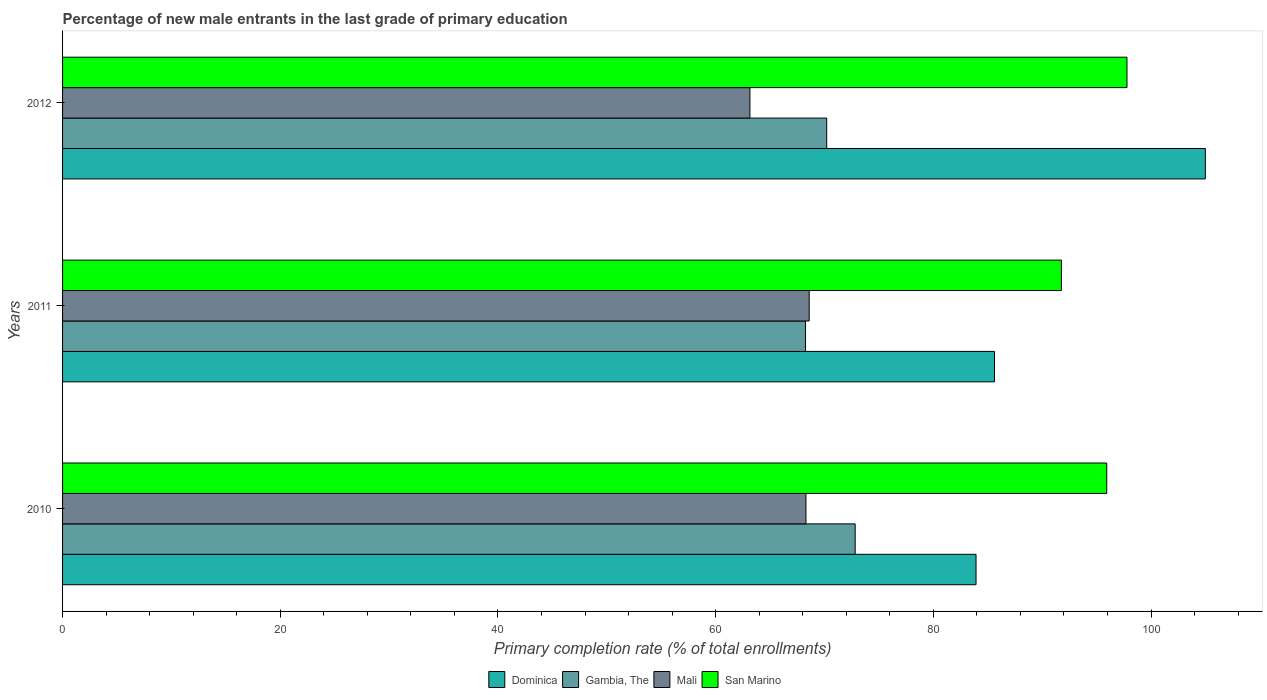How many different coloured bars are there?
Your answer should be compact. 4. Are the number of bars per tick equal to the number of legend labels?
Make the answer very short. Yes. What is the label of the 3rd group of bars from the top?
Make the answer very short. 2010. In how many cases, is the number of bars for a given year not equal to the number of legend labels?
Your answer should be very brief. 0. What is the percentage of new male entrants in Dominica in 2010?
Keep it short and to the point. 83.92. Across all years, what is the maximum percentage of new male entrants in Mali?
Make the answer very short. 68.6. Across all years, what is the minimum percentage of new male entrants in Mali?
Offer a very short reply. 63.15. What is the total percentage of new male entrants in San Marino in the graph?
Make the answer very short. 285.49. What is the difference between the percentage of new male entrants in Dominica in 2011 and that in 2012?
Your response must be concise. -19.37. What is the difference between the percentage of new male entrants in Gambia, The in 2011 and the percentage of new male entrants in San Marino in 2012?
Your response must be concise. -29.53. What is the average percentage of new male entrants in Gambia, The per year?
Your response must be concise. 70.43. In the year 2011, what is the difference between the percentage of new male entrants in Dominica and percentage of new male entrants in Gambia, The?
Provide a succinct answer. 17.36. In how many years, is the percentage of new male entrants in Dominica greater than 52 %?
Give a very brief answer. 3. What is the ratio of the percentage of new male entrants in Gambia, The in 2010 to that in 2012?
Offer a terse response. 1.04. Is the percentage of new male entrants in San Marino in 2011 less than that in 2012?
Provide a succinct answer. Yes. What is the difference between the highest and the second highest percentage of new male entrants in Mali?
Provide a short and direct response. 0.3. What is the difference between the highest and the lowest percentage of new male entrants in Dominica?
Your response must be concise. 21.07. In how many years, is the percentage of new male entrants in Mali greater than the average percentage of new male entrants in Mali taken over all years?
Ensure brevity in your answer.  2. Is the sum of the percentage of new male entrants in San Marino in 2010 and 2011 greater than the maximum percentage of new male entrants in Gambia, The across all years?
Ensure brevity in your answer.  Yes. Is it the case that in every year, the sum of the percentage of new male entrants in Dominica and percentage of new male entrants in Gambia, The is greater than the sum of percentage of new male entrants in San Marino and percentage of new male entrants in Mali?
Provide a short and direct response. Yes. What does the 3rd bar from the top in 2012 represents?
Provide a short and direct response. Gambia, The. What does the 4th bar from the bottom in 2010 represents?
Give a very brief answer. San Marino. Are all the bars in the graph horizontal?
Keep it short and to the point. Yes. Does the graph contain any zero values?
Give a very brief answer. No. What is the title of the graph?
Offer a terse response. Percentage of new male entrants in the last grade of primary education. What is the label or title of the X-axis?
Your answer should be very brief. Primary completion rate (% of total enrollments). What is the label or title of the Y-axis?
Ensure brevity in your answer.  Years. What is the Primary completion rate (% of total enrollments) in Dominica in 2010?
Your answer should be compact. 83.92. What is the Primary completion rate (% of total enrollments) of Gambia, The in 2010?
Ensure brevity in your answer.  72.82. What is the Primary completion rate (% of total enrollments) in Mali in 2010?
Ensure brevity in your answer.  68.3. What is the Primary completion rate (% of total enrollments) in San Marino in 2010?
Make the answer very short. 95.93. What is the Primary completion rate (% of total enrollments) in Dominica in 2011?
Offer a terse response. 85.62. What is the Primary completion rate (% of total enrollments) in Gambia, The in 2011?
Your response must be concise. 68.26. What is the Primary completion rate (% of total enrollments) in Mali in 2011?
Your response must be concise. 68.6. What is the Primary completion rate (% of total enrollments) in San Marino in 2011?
Your response must be concise. 91.76. What is the Primary completion rate (% of total enrollments) in Dominica in 2012?
Offer a very short reply. 104.99. What is the Primary completion rate (% of total enrollments) of Gambia, The in 2012?
Offer a very short reply. 70.2. What is the Primary completion rate (% of total enrollments) of Mali in 2012?
Provide a succinct answer. 63.15. What is the Primary completion rate (% of total enrollments) in San Marino in 2012?
Offer a terse response. 97.79. Across all years, what is the maximum Primary completion rate (% of total enrollments) of Dominica?
Provide a short and direct response. 104.99. Across all years, what is the maximum Primary completion rate (% of total enrollments) in Gambia, The?
Your response must be concise. 72.82. Across all years, what is the maximum Primary completion rate (% of total enrollments) of Mali?
Provide a succinct answer. 68.6. Across all years, what is the maximum Primary completion rate (% of total enrollments) of San Marino?
Give a very brief answer. 97.79. Across all years, what is the minimum Primary completion rate (% of total enrollments) of Dominica?
Make the answer very short. 83.92. Across all years, what is the minimum Primary completion rate (% of total enrollments) of Gambia, The?
Provide a short and direct response. 68.26. Across all years, what is the minimum Primary completion rate (% of total enrollments) of Mali?
Your response must be concise. 63.15. Across all years, what is the minimum Primary completion rate (% of total enrollments) of San Marino?
Offer a terse response. 91.76. What is the total Primary completion rate (% of total enrollments) of Dominica in the graph?
Make the answer very short. 274.53. What is the total Primary completion rate (% of total enrollments) of Gambia, The in the graph?
Offer a very short reply. 211.28. What is the total Primary completion rate (% of total enrollments) in Mali in the graph?
Give a very brief answer. 200.04. What is the total Primary completion rate (% of total enrollments) of San Marino in the graph?
Offer a terse response. 285.49. What is the difference between the Primary completion rate (% of total enrollments) of Dominica in 2010 and that in 2011?
Provide a short and direct response. -1.69. What is the difference between the Primary completion rate (% of total enrollments) in Gambia, The in 2010 and that in 2011?
Your answer should be compact. 4.56. What is the difference between the Primary completion rate (% of total enrollments) in Mali in 2010 and that in 2011?
Provide a short and direct response. -0.3. What is the difference between the Primary completion rate (% of total enrollments) in San Marino in 2010 and that in 2011?
Offer a terse response. 4.17. What is the difference between the Primary completion rate (% of total enrollments) in Dominica in 2010 and that in 2012?
Keep it short and to the point. -21.07. What is the difference between the Primary completion rate (% of total enrollments) of Gambia, The in 2010 and that in 2012?
Give a very brief answer. 2.62. What is the difference between the Primary completion rate (% of total enrollments) of Mali in 2010 and that in 2012?
Offer a terse response. 5.15. What is the difference between the Primary completion rate (% of total enrollments) in San Marino in 2010 and that in 2012?
Keep it short and to the point. -1.86. What is the difference between the Primary completion rate (% of total enrollments) of Dominica in 2011 and that in 2012?
Your answer should be compact. -19.37. What is the difference between the Primary completion rate (% of total enrollments) of Gambia, The in 2011 and that in 2012?
Keep it short and to the point. -1.95. What is the difference between the Primary completion rate (% of total enrollments) of Mali in 2011 and that in 2012?
Ensure brevity in your answer.  5.45. What is the difference between the Primary completion rate (% of total enrollments) of San Marino in 2011 and that in 2012?
Give a very brief answer. -6.03. What is the difference between the Primary completion rate (% of total enrollments) in Dominica in 2010 and the Primary completion rate (% of total enrollments) in Gambia, The in 2011?
Your response must be concise. 15.66. What is the difference between the Primary completion rate (% of total enrollments) in Dominica in 2010 and the Primary completion rate (% of total enrollments) in Mali in 2011?
Provide a short and direct response. 15.33. What is the difference between the Primary completion rate (% of total enrollments) in Dominica in 2010 and the Primary completion rate (% of total enrollments) in San Marino in 2011?
Give a very brief answer. -7.84. What is the difference between the Primary completion rate (% of total enrollments) in Gambia, The in 2010 and the Primary completion rate (% of total enrollments) in Mali in 2011?
Give a very brief answer. 4.22. What is the difference between the Primary completion rate (% of total enrollments) in Gambia, The in 2010 and the Primary completion rate (% of total enrollments) in San Marino in 2011?
Your answer should be compact. -18.95. What is the difference between the Primary completion rate (% of total enrollments) in Mali in 2010 and the Primary completion rate (% of total enrollments) in San Marino in 2011?
Your response must be concise. -23.47. What is the difference between the Primary completion rate (% of total enrollments) in Dominica in 2010 and the Primary completion rate (% of total enrollments) in Gambia, The in 2012?
Your answer should be compact. 13.72. What is the difference between the Primary completion rate (% of total enrollments) of Dominica in 2010 and the Primary completion rate (% of total enrollments) of Mali in 2012?
Ensure brevity in your answer.  20.77. What is the difference between the Primary completion rate (% of total enrollments) of Dominica in 2010 and the Primary completion rate (% of total enrollments) of San Marino in 2012?
Your answer should be very brief. -13.87. What is the difference between the Primary completion rate (% of total enrollments) of Gambia, The in 2010 and the Primary completion rate (% of total enrollments) of Mali in 2012?
Make the answer very short. 9.67. What is the difference between the Primary completion rate (% of total enrollments) of Gambia, The in 2010 and the Primary completion rate (% of total enrollments) of San Marino in 2012?
Keep it short and to the point. -24.97. What is the difference between the Primary completion rate (% of total enrollments) of Mali in 2010 and the Primary completion rate (% of total enrollments) of San Marino in 2012?
Your response must be concise. -29.49. What is the difference between the Primary completion rate (% of total enrollments) in Dominica in 2011 and the Primary completion rate (% of total enrollments) in Gambia, The in 2012?
Make the answer very short. 15.41. What is the difference between the Primary completion rate (% of total enrollments) in Dominica in 2011 and the Primary completion rate (% of total enrollments) in Mali in 2012?
Your response must be concise. 22.47. What is the difference between the Primary completion rate (% of total enrollments) in Dominica in 2011 and the Primary completion rate (% of total enrollments) in San Marino in 2012?
Offer a very short reply. -12.17. What is the difference between the Primary completion rate (% of total enrollments) in Gambia, The in 2011 and the Primary completion rate (% of total enrollments) in Mali in 2012?
Keep it short and to the point. 5.11. What is the difference between the Primary completion rate (% of total enrollments) in Gambia, The in 2011 and the Primary completion rate (% of total enrollments) in San Marino in 2012?
Your answer should be compact. -29.53. What is the difference between the Primary completion rate (% of total enrollments) of Mali in 2011 and the Primary completion rate (% of total enrollments) of San Marino in 2012?
Give a very brief answer. -29.19. What is the average Primary completion rate (% of total enrollments) of Dominica per year?
Make the answer very short. 91.51. What is the average Primary completion rate (% of total enrollments) in Gambia, The per year?
Keep it short and to the point. 70.43. What is the average Primary completion rate (% of total enrollments) of Mali per year?
Give a very brief answer. 66.68. What is the average Primary completion rate (% of total enrollments) in San Marino per year?
Offer a very short reply. 95.16. In the year 2010, what is the difference between the Primary completion rate (% of total enrollments) in Dominica and Primary completion rate (% of total enrollments) in Gambia, The?
Offer a terse response. 11.1. In the year 2010, what is the difference between the Primary completion rate (% of total enrollments) of Dominica and Primary completion rate (% of total enrollments) of Mali?
Keep it short and to the point. 15.63. In the year 2010, what is the difference between the Primary completion rate (% of total enrollments) in Dominica and Primary completion rate (% of total enrollments) in San Marino?
Ensure brevity in your answer.  -12.01. In the year 2010, what is the difference between the Primary completion rate (% of total enrollments) in Gambia, The and Primary completion rate (% of total enrollments) in Mali?
Your response must be concise. 4.52. In the year 2010, what is the difference between the Primary completion rate (% of total enrollments) in Gambia, The and Primary completion rate (% of total enrollments) in San Marino?
Ensure brevity in your answer.  -23.11. In the year 2010, what is the difference between the Primary completion rate (% of total enrollments) of Mali and Primary completion rate (% of total enrollments) of San Marino?
Offer a terse response. -27.63. In the year 2011, what is the difference between the Primary completion rate (% of total enrollments) in Dominica and Primary completion rate (% of total enrollments) in Gambia, The?
Ensure brevity in your answer.  17.36. In the year 2011, what is the difference between the Primary completion rate (% of total enrollments) of Dominica and Primary completion rate (% of total enrollments) of Mali?
Offer a terse response. 17.02. In the year 2011, what is the difference between the Primary completion rate (% of total enrollments) in Dominica and Primary completion rate (% of total enrollments) in San Marino?
Your answer should be very brief. -6.15. In the year 2011, what is the difference between the Primary completion rate (% of total enrollments) in Gambia, The and Primary completion rate (% of total enrollments) in Mali?
Provide a succinct answer. -0.34. In the year 2011, what is the difference between the Primary completion rate (% of total enrollments) of Gambia, The and Primary completion rate (% of total enrollments) of San Marino?
Offer a very short reply. -23.51. In the year 2011, what is the difference between the Primary completion rate (% of total enrollments) in Mali and Primary completion rate (% of total enrollments) in San Marino?
Offer a very short reply. -23.17. In the year 2012, what is the difference between the Primary completion rate (% of total enrollments) in Dominica and Primary completion rate (% of total enrollments) in Gambia, The?
Give a very brief answer. 34.79. In the year 2012, what is the difference between the Primary completion rate (% of total enrollments) in Dominica and Primary completion rate (% of total enrollments) in Mali?
Provide a succinct answer. 41.84. In the year 2012, what is the difference between the Primary completion rate (% of total enrollments) in Dominica and Primary completion rate (% of total enrollments) in San Marino?
Provide a succinct answer. 7.2. In the year 2012, what is the difference between the Primary completion rate (% of total enrollments) in Gambia, The and Primary completion rate (% of total enrollments) in Mali?
Ensure brevity in your answer.  7.05. In the year 2012, what is the difference between the Primary completion rate (% of total enrollments) in Gambia, The and Primary completion rate (% of total enrollments) in San Marino?
Offer a terse response. -27.59. In the year 2012, what is the difference between the Primary completion rate (% of total enrollments) of Mali and Primary completion rate (% of total enrollments) of San Marino?
Your response must be concise. -34.64. What is the ratio of the Primary completion rate (% of total enrollments) of Dominica in 2010 to that in 2011?
Keep it short and to the point. 0.98. What is the ratio of the Primary completion rate (% of total enrollments) of Gambia, The in 2010 to that in 2011?
Offer a very short reply. 1.07. What is the ratio of the Primary completion rate (% of total enrollments) of San Marino in 2010 to that in 2011?
Your answer should be very brief. 1.05. What is the ratio of the Primary completion rate (% of total enrollments) in Dominica in 2010 to that in 2012?
Provide a short and direct response. 0.8. What is the ratio of the Primary completion rate (% of total enrollments) of Gambia, The in 2010 to that in 2012?
Provide a short and direct response. 1.04. What is the ratio of the Primary completion rate (% of total enrollments) of Mali in 2010 to that in 2012?
Your answer should be very brief. 1.08. What is the ratio of the Primary completion rate (% of total enrollments) of Dominica in 2011 to that in 2012?
Make the answer very short. 0.82. What is the ratio of the Primary completion rate (% of total enrollments) of Gambia, The in 2011 to that in 2012?
Your answer should be very brief. 0.97. What is the ratio of the Primary completion rate (% of total enrollments) of Mali in 2011 to that in 2012?
Keep it short and to the point. 1.09. What is the ratio of the Primary completion rate (% of total enrollments) of San Marino in 2011 to that in 2012?
Your answer should be very brief. 0.94. What is the difference between the highest and the second highest Primary completion rate (% of total enrollments) of Dominica?
Offer a terse response. 19.37. What is the difference between the highest and the second highest Primary completion rate (% of total enrollments) of Gambia, The?
Provide a succinct answer. 2.62. What is the difference between the highest and the second highest Primary completion rate (% of total enrollments) of Mali?
Your answer should be very brief. 0.3. What is the difference between the highest and the second highest Primary completion rate (% of total enrollments) of San Marino?
Provide a short and direct response. 1.86. What is the difference between the highest and the lowest Primary completion rate (% of total enrollments) in Dominica?
Your answer should be compact. 21.07. What is the difference between the highest and the lowest Primary completion rate (% of total enrollments) in Gambia, The?
Your response must be concise. 4.56. What is the difference between the highest and the lowest Primary completion rate (% of total enrollments) in Mali?
Offer a very short reply. 5.45. What is the difference between the highest and the lowest Primary completion rate (% of total enrollments) in San Marino?
Keep it short and to the point. 6.03. 